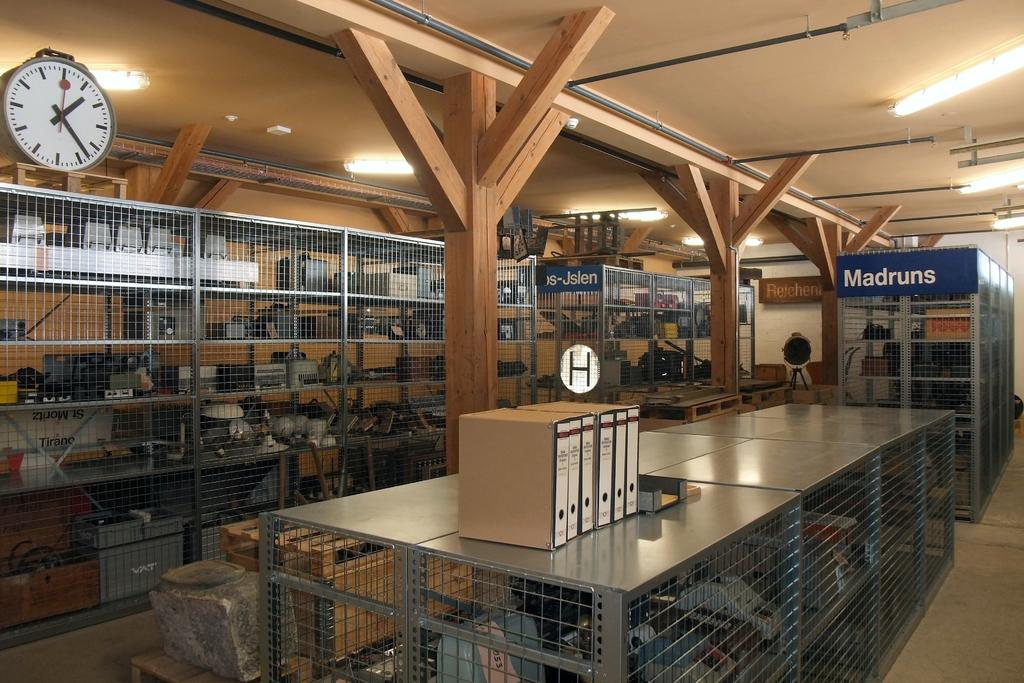<image>
Present a compact description of the photo's key features. stacks of items on shelves behind bars with on labels madruns 